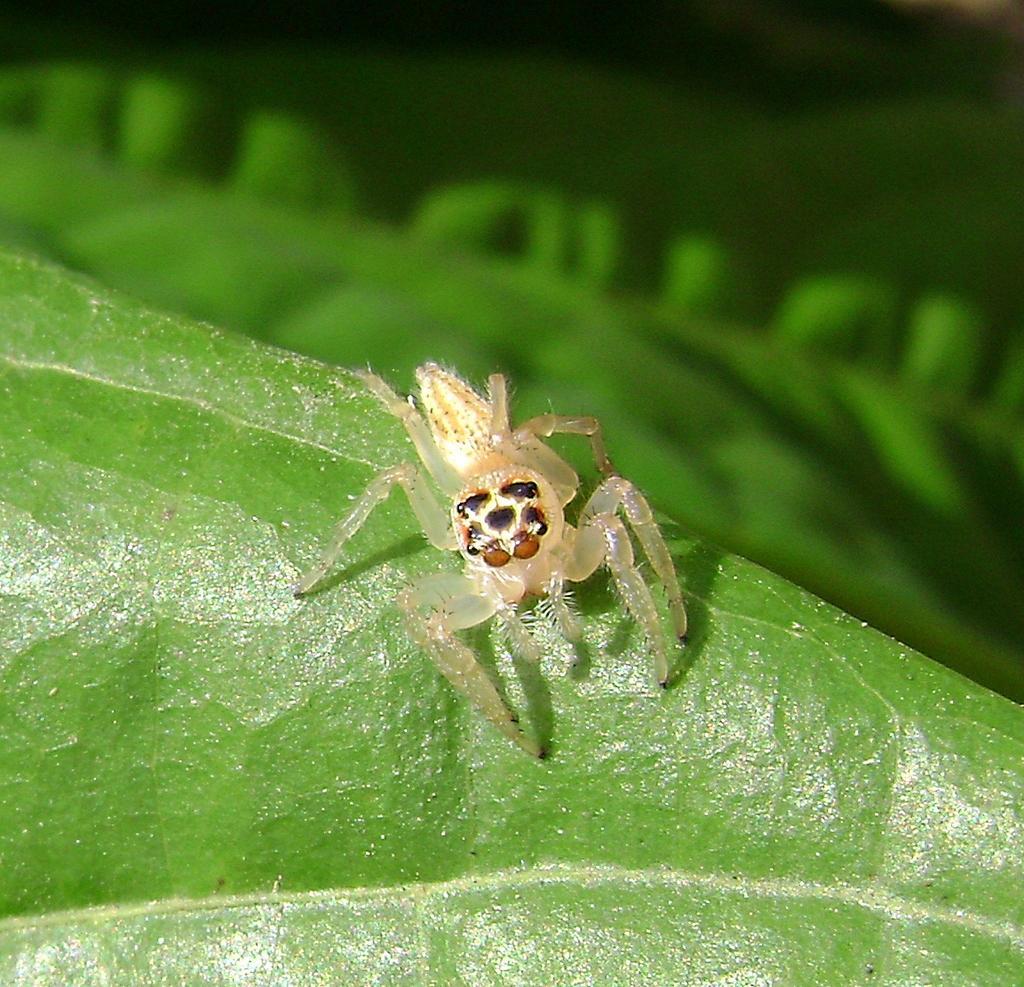How would you summarize this image in a sentence or two? In this image I can see an insect and the insect is on the green color surface and I can see the blurred background. 